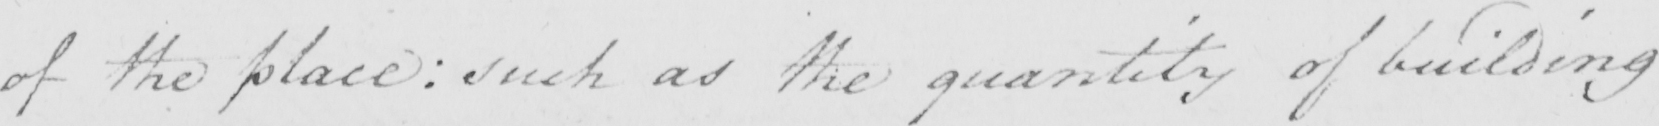Please transcribe the handwritten text in this image. of the place :  such as the quantity of building 